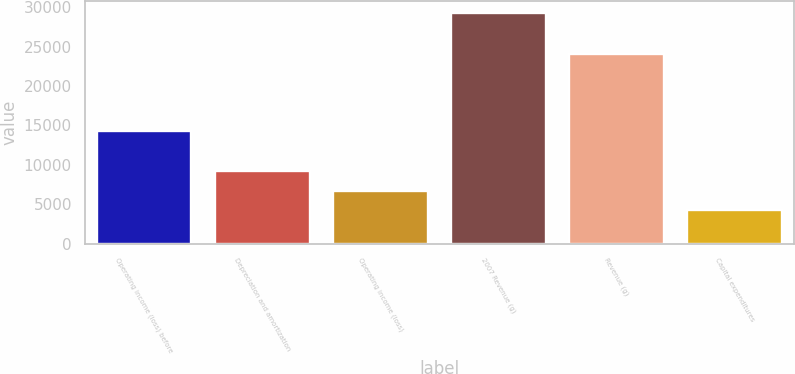<chart> <loc_0><loc_0><loc_500><loc_500><bar_chart><fcel>Operating income (loss) before<fcel>Depreciation and amortization<fcel>Operating income (loss)<fcel>2007 Revenue (g)<fcel>Revenue (g)<fcel>Capital expenditures<nl><fcel>14268.4<fcel>9256.2<fcel>6750.1<fcel>29305<fcel>24042<fcel>4244<nl></chart> 